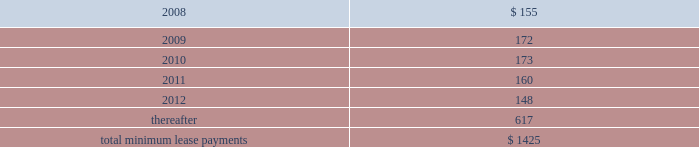Notes to consolidated financial statements ( continued ) note 8 2014commitments and contingencies ( continued ) provide renewal options for terms of 3 to 7 additional years .
Leases for retail space are for terms of 5 to 20 years , the majority of which are for 10 years , and often contain multi-year renewal options .
As of september 29 , 2007 , the company 2019s total future minimum lease payments under noncancelable operating leases were $ 1.4 billion , of which $ 1.1 billion related to leases for retail space .
Rent expense under all operating leases , including both cancelable and noncancelable leases , was $ 151 million , $ 138 million , and $ 140 million in 2007 , 2006 , and 2005 , respectively .
Future minimum lease payments under noncancelable operating leases having remaining terms in excess of one year as of september 29 , 2007 , are as follows ( in millions ) : fiscal years .
Accrued warranty and indemnifications the company offers a basic limited parts and labor warranty on its hardware products .
The basic warranty period for hardware products is typically one year from the date of purchase by the end-user .
The company also offers a 90-day basic warranty for its service parts used to repair the company 2019s hardware products .
The company provides currently for the estimated cost that may be incurred under its basic limited product warranties at the time related revenue is recognized .
Factors considered in determining appropriate accruals for product warranty obligations include the size of the installed base of products subject to warranty protection , historical and projected warranty claim rates , historical and projected cost-per-claim , and knowledge of specific product failures that are outside of the company 2019s typical experience .
The company assesses the adequacy of its preexisting warranty liabilities and adjusts the amounts as necessary based on actual experience and changes in future estimates .
For products accounted for under subscription accounting pursuant to sop no .
97-2 , the company recognizes warranty expense as incurred .
The company periodically provides updates to its applications and system software to maintain the software 2019s compliance with specifications .
The estimated cost to develop such updates is accounted for as warranty costs that are recognized at the time related software revenue is recognized .
Factors considered in determining appropriate accruals related to such updates include the number of units delivered , the number of updates expected to occur , and the historical cost and estimated future cost of the resources necessary to develop these updates. .
As of september 29 , 2007 , what percent of the company 2019s total future minimum lease payments under noncancelable operating leases were related to leases for retail space? 
Computations: (1.1 / 1.4)
Answer: 0.78571. 